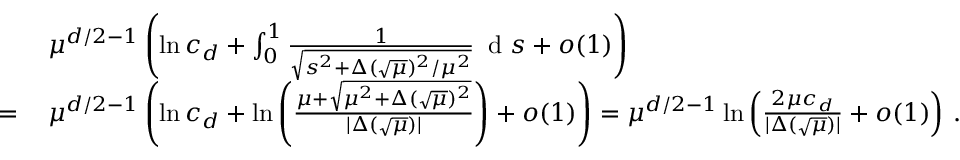<formula> <loc_0><loc_0><loc_500><loc_500>\begin{array} { r l } & { \mu ^ { d / 2 - 1 } \left ( \ln c _ { d } + \int _ { 0 } ^ { 1 } \frac { 1 } { \sqrt { s ^ { 2 } + \Delta ( \sqrt { \mu } ) ^ { 2 } / \mu ^ { 2 } } } \, d s + o ( 1 ) \right ) } \\ { = \, } & { \mu ^ { d / 2 - 1 } \left ( \ln c _ { d } + \ln \left ( \frac { \mu + \sqrt { \mu ^ { 2 } + \Delta ( \sqrt { \mu } ) ^ { 2 } } } { | \Delta ( \sqrt { \mu } ) | } \right ) + o ( 1 ) \right ) = \mu ^ { d / 2 - 1 } \ln \left ( \frac { 2 \mu c _ { d } } { | \Delta ( \sqrt { \mu } ) | } + o ( 1 ) \right ) \, . } \end{array}</formula> 